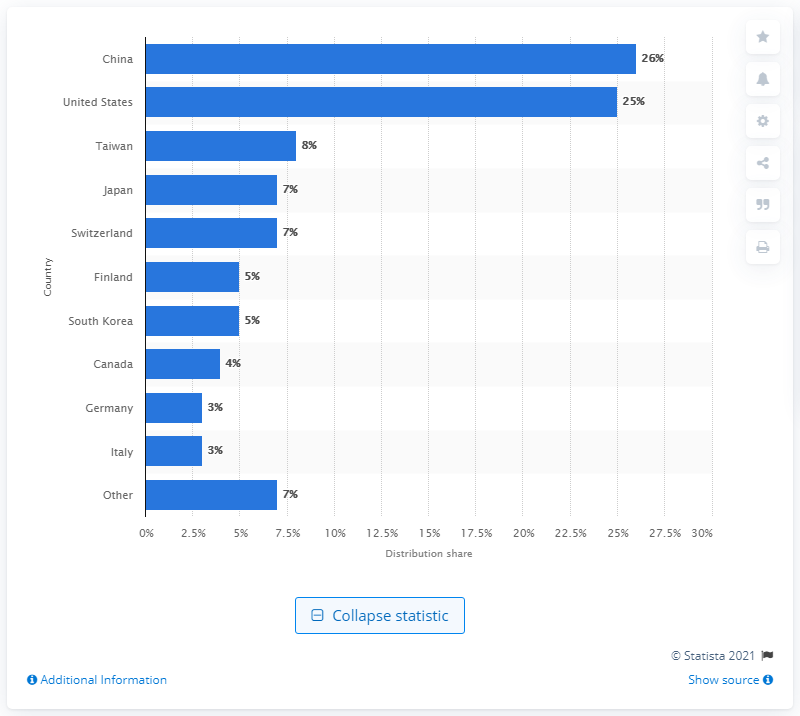List a handful of essential elements in this visual. In 2013, a significant 26% of smartwatch companies were located in China. 